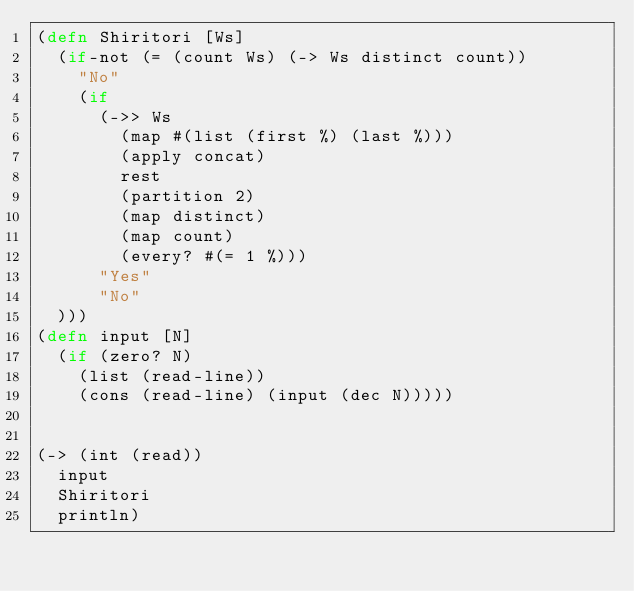Convert code to text. <code><loc_0><loc_0><loc_500><loc_500><_Clojure_>(defn Shiritori [Ws]
  (if-not (= (count Ws) (-> Ws distinct count))
    "No"
    (if 
      (->> Ws 
        (map #(list (first %) (last %))) 
        (apply concat) 
        rest 
        (partition 2)
        (map distinct) 
        (map count) 
        (every? #(= 1 %)))
      "Yes"
      "No"
  )))
(defn input [N]
  (if (zero? N) 
    (list (read-line))
    (cons (read-line) (input (dec N)))))


(-> (int (read))
  input
  Shiritori
  println)</code> 